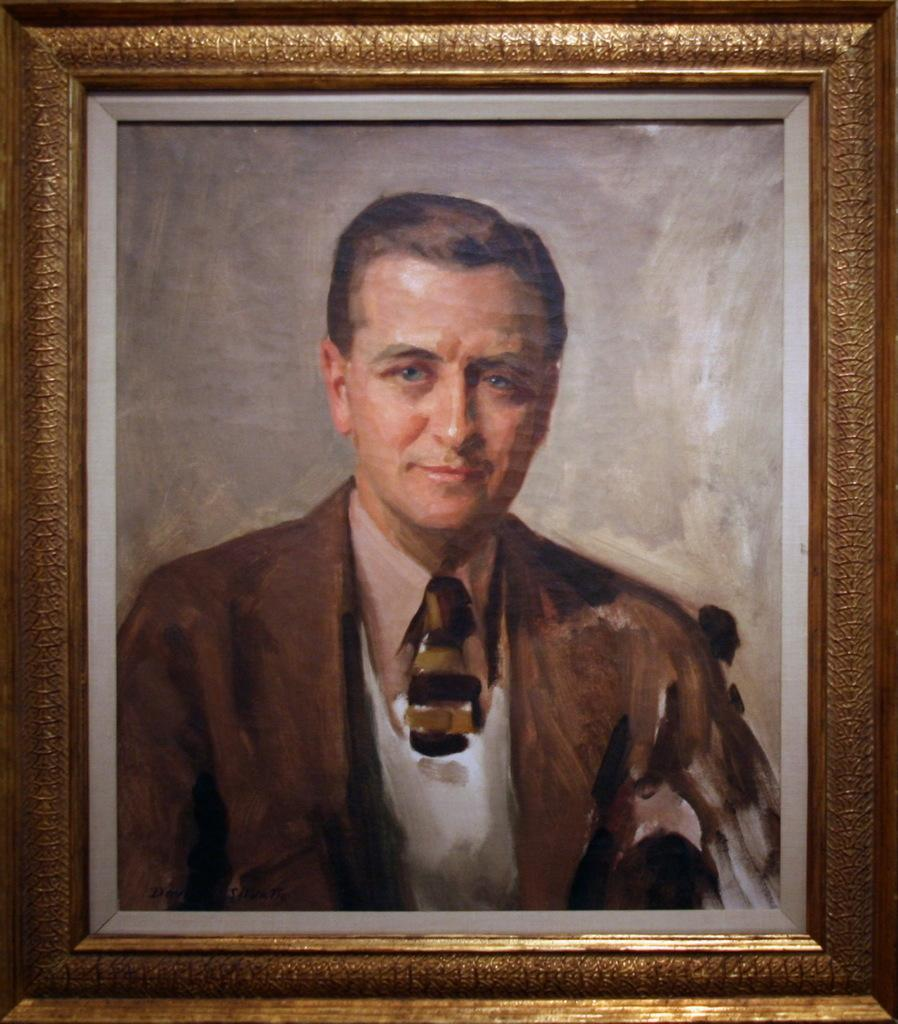What type of object is the main subject of the image? The image is a photo frame. What is depicted within the photo frame? There is a painting of a man smiling in the frame. What is the color of the photo frame? The frame has a golden color. Can you see a stream of water flowing through the painting in the image? There is no stream of water present in the painting; it depicts a man smiling. 